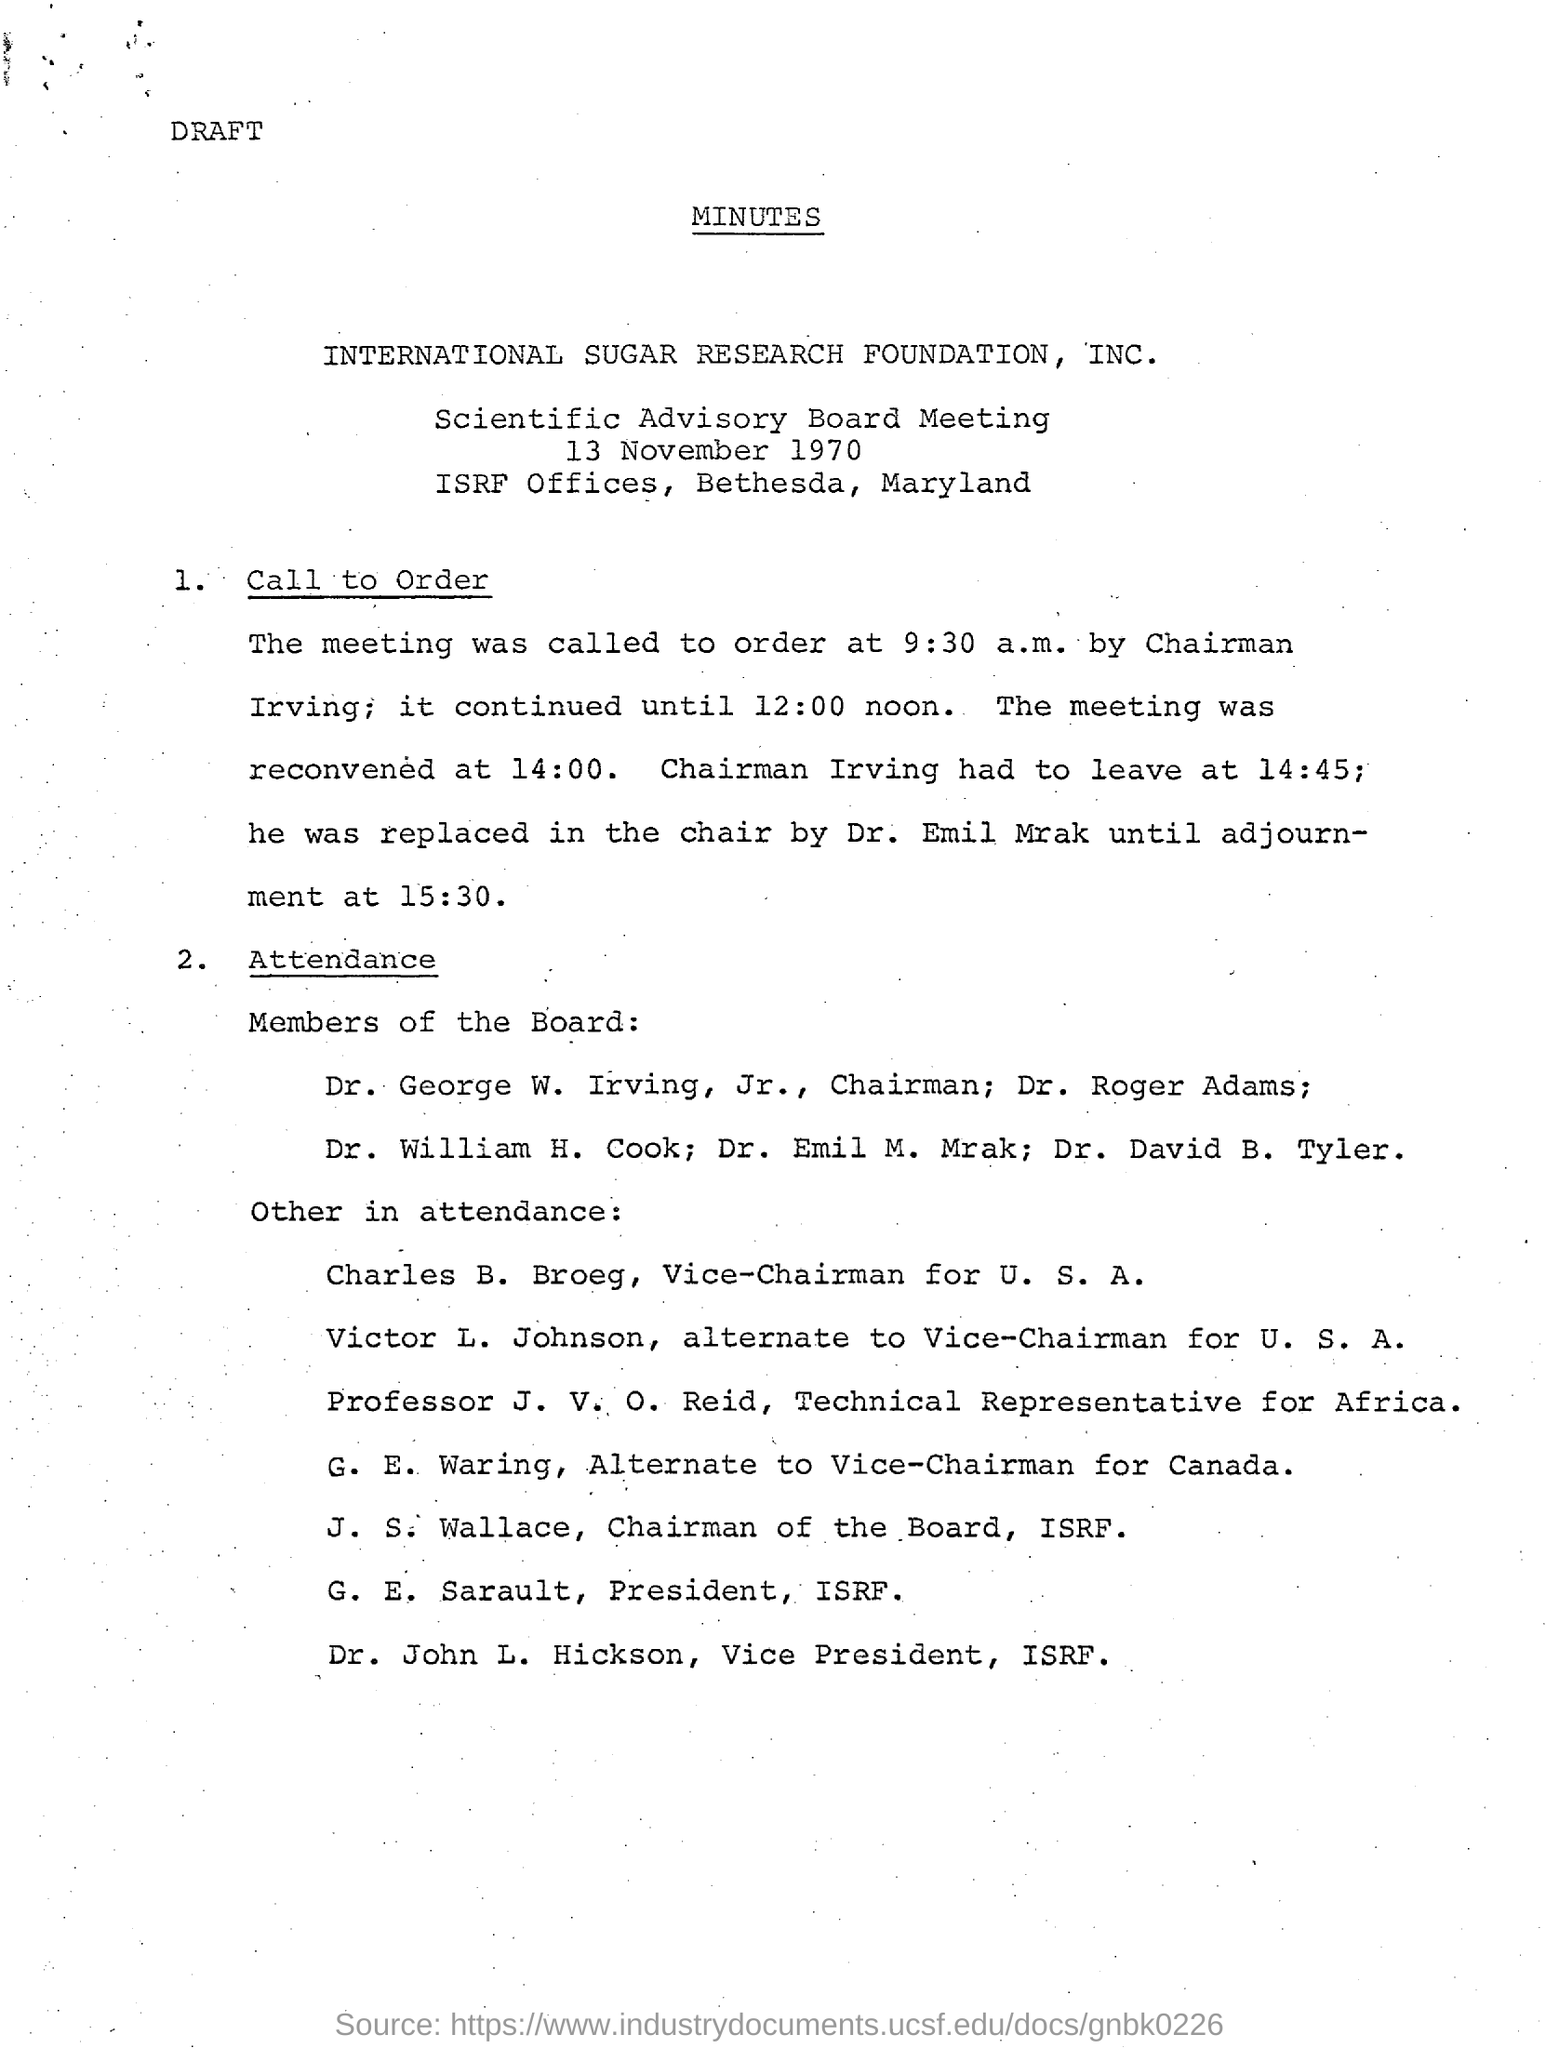When was the meeting called to order?
Your answer should be very brief. 9:30 a.m. Who called the meeting to order?
Your answer should be very brief. Chairman Irving. When was the meeting reconvened?
Provide a short and direct response. 14:00. When did Chairman Irving leave?
Your answer should be very brief. 14:45. When was the adjourment?
Ensure brevity in your answer.  15:30. 